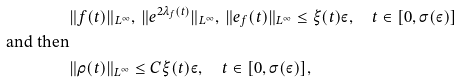<formula> <loc_0><loc_0><loc_500><loc_500>& \| f ( t ) \| _ { L ^ { \infty } } , \, \| e ^ { 2 \lambda _ { f } ( t ) } \| _ { L ^ { \infty } } , \, \| e _ { f } ( t ) \| _ { L ^ { \infty } } \leq \xi ( t ) \varepsilon , \quad t \in [ 0 , \sigma ( \varepsilon ) ] \\ \text {and then} \\ & \| \rho ( t ) \| _ { L ^ { \infty } } \leq C \xi ( t ) \varepsilon , \quad t \in [ 0 , \sigma ( \varepsilon ) ] ,</formula> 